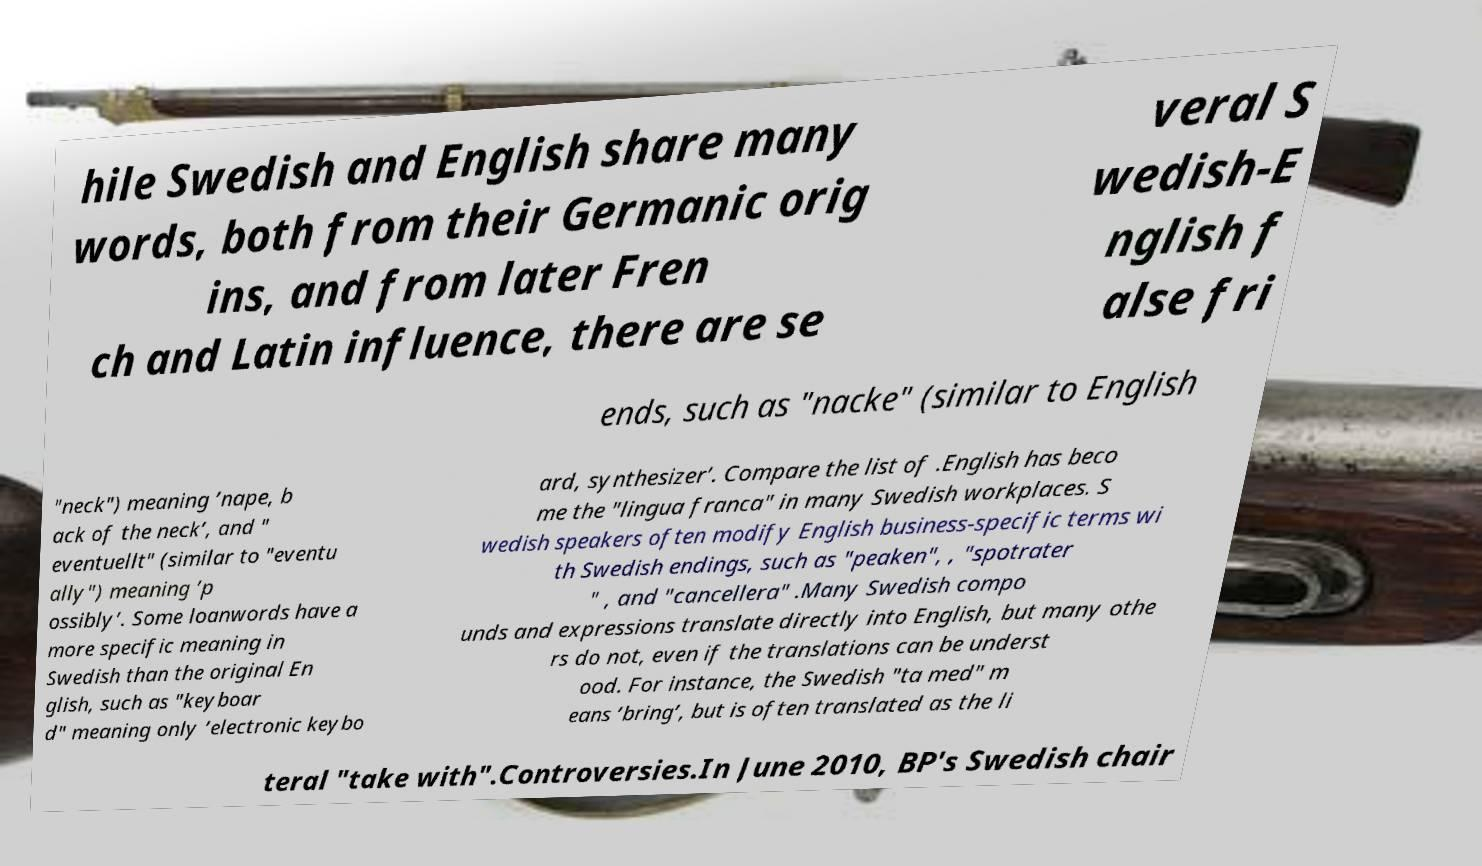For documentation purposes, I need the text within this image transcribed. Could you provide that? hile Swedish and English share many words, both from their Germanic orig ins, and from later Fren ch and Latin influence, there are se veral S wedish-E nglish f alse fri ends, such as "nacke" (similar to English "neck") meaning ’nape, b ack of the neck’, and " eventuellt" (similar to "eventu ally") meaning ’p ossibly’. Some loanwords have a more specific meaning in Swedish than the original En glish, such as "keyboar d" meaning only ’electronic keybo ard, synthesizer’. Compare the list of .English has beco me the "lingua franca" in many Swedish workplaces. S wedish speakers often modify English business-specific terms wi th Swedish endings, such as "peaken", , "spotrater " , and "cancellera" .Many Swedish compo unds and expressions translate directly into English, but many othe rs do not, even if the translations can be underst ood. For instance, the Swedish "ta med" m eans ’bring’, but is often translated as the li teral "take with".Controversies.In June 2010, BP's Swedish chair 